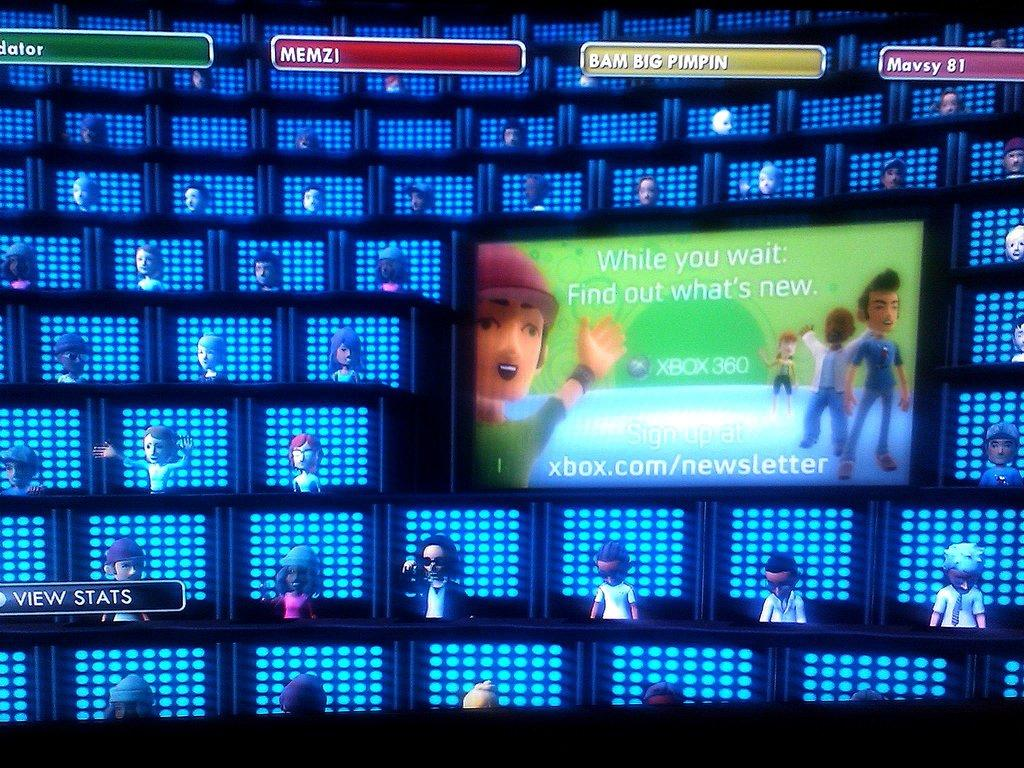<image>
Describe the image concisely. Digital avatars sit in rows of LED boxes with an advertisement for the Xbox Newsletter is displayed on a screen. 